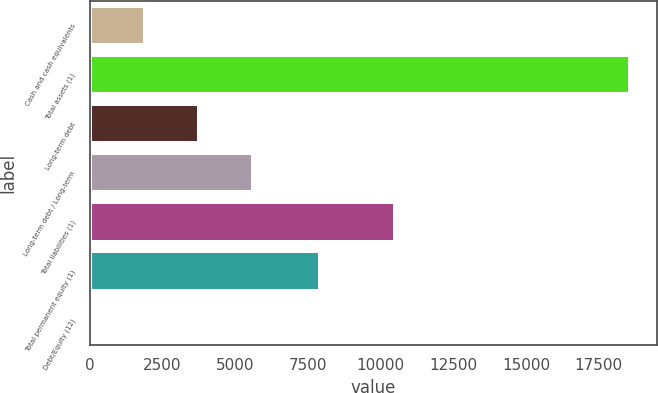Convert chart. <chart><loc_0><loc_0><loc_500><loc_500><bar_chart><fcel>Cash and cash equivalents<fcel>Total assets (1)<fcel>Long-term debt<fcel>Long-term debt / Long-term<fcel>Total liabilities (1)<fcel>Total permanent equity (1)<fcel>Debt/Equity (12)<nl><fcel>1882.86<fcel>18593.7<fcel>3739.62<fcel>5596.38<fcel>10499.5<fcel>7926.9<fcel>26.1<nl></chart> 